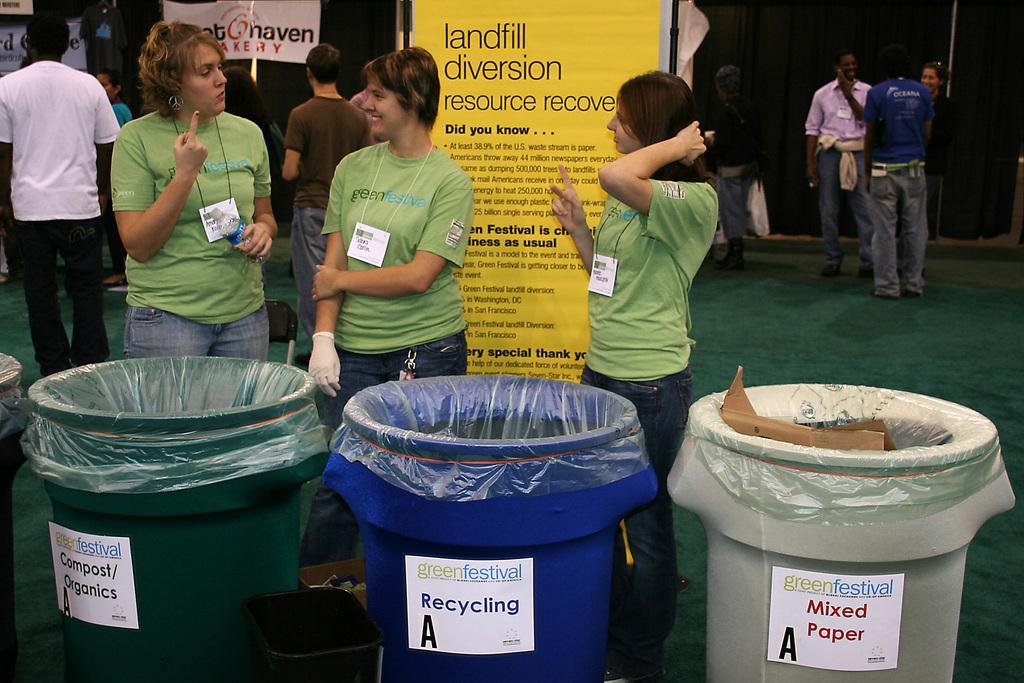What festival is it?
Your answer should be very brief. Green. What goes in the green trash can?
Provide a short and direct response. Compost/organics. 